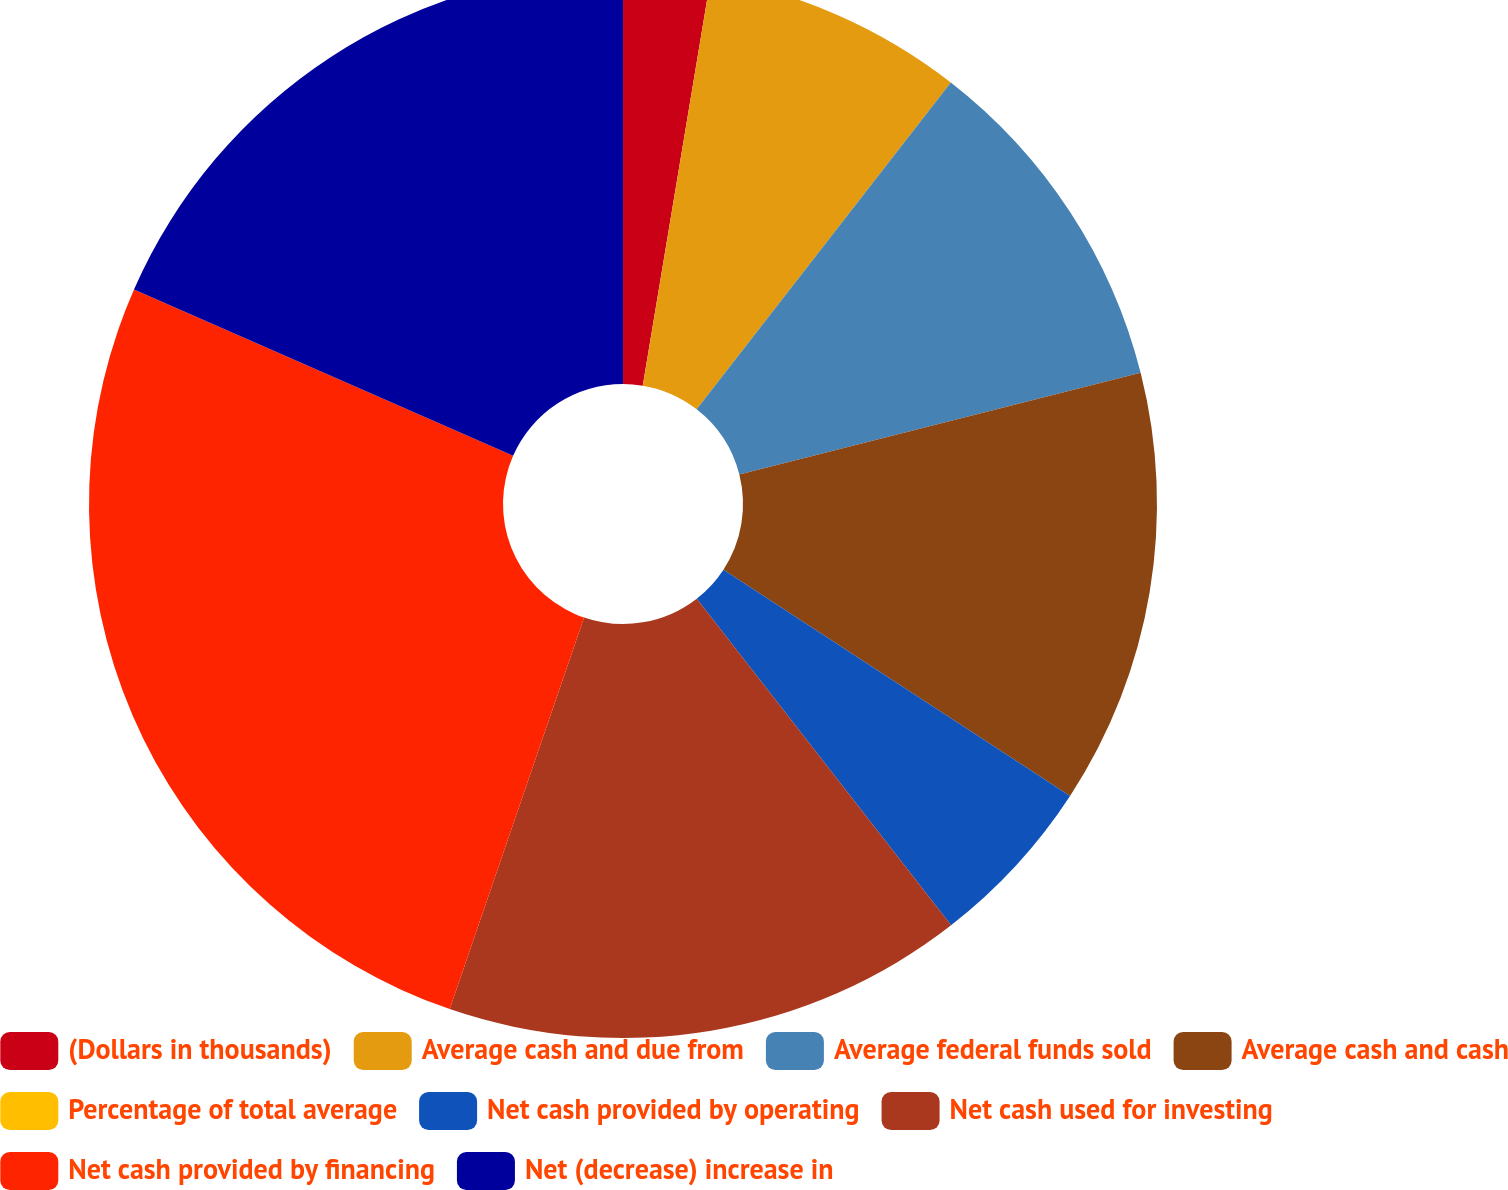Convert chart to OTSL. <chart><loc_0><loc_0><loc_500><loc_500><pie_chart><fcel>(Dollars in thousands)<fcel>Average cash and due from<fcel>Average federal funds sold<fcel>Average cash and cash<fcel>Percentage of total average<fcel>Net cash provided by operating<fcel>Net cash used for investing<fcel>Net cash provided by financing<fcel>Net (decrease) increase in<nl><fcel>2.63%<fcel>7.89%<fcel>10.53%<fcel>13.16%<fcel>0.0%<fcel>5.26%<fcel>15.79%<fcel>26.32%<fcel>18.42%<nl></chart> 